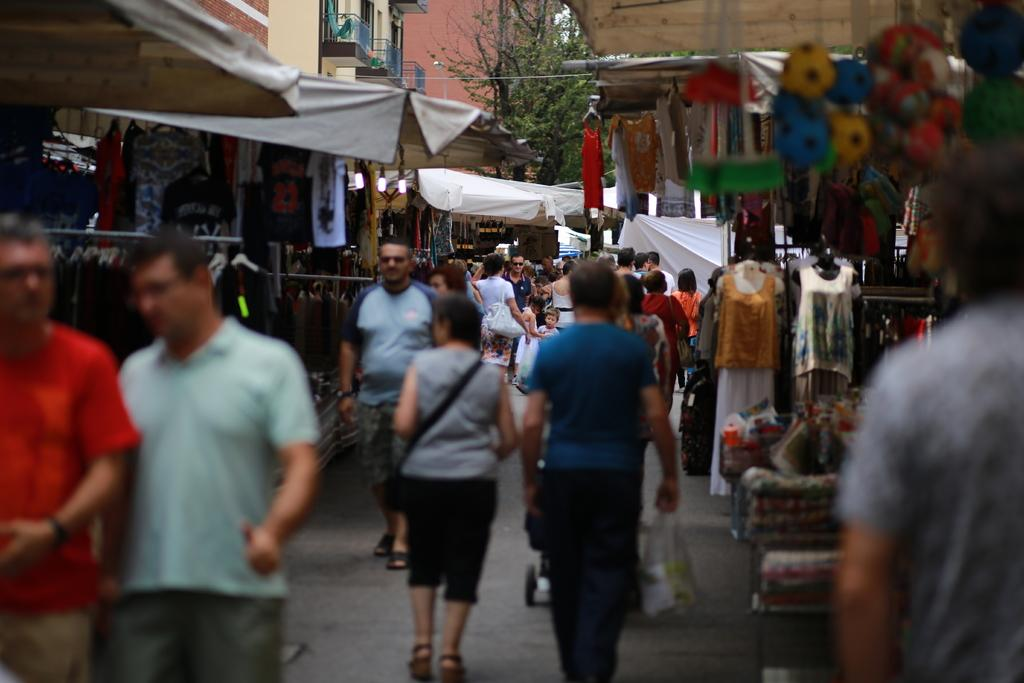How many people are in the image? There is a group of people in the image, but the exact number is not specified. What can be seen in the background of the image? In the background of the image, there are clothes, balloons, mannequins, curtains, other unspecified things, buildings, and trees. Can you describe the setting of the image? The image appears to be set in an area with a mix of urban and natural elements, as evidenced by the presence of buildings and trees in the background. What type of mist can be seen covering the protest in the image? There is no protest or mist present in the image; it features a group of people in an area with a mix of urban and natural elements. What kind of bird is perched on the mannequin in the image? There is no bird present in the image; it features a group of people and various background elements, including mannequins. 